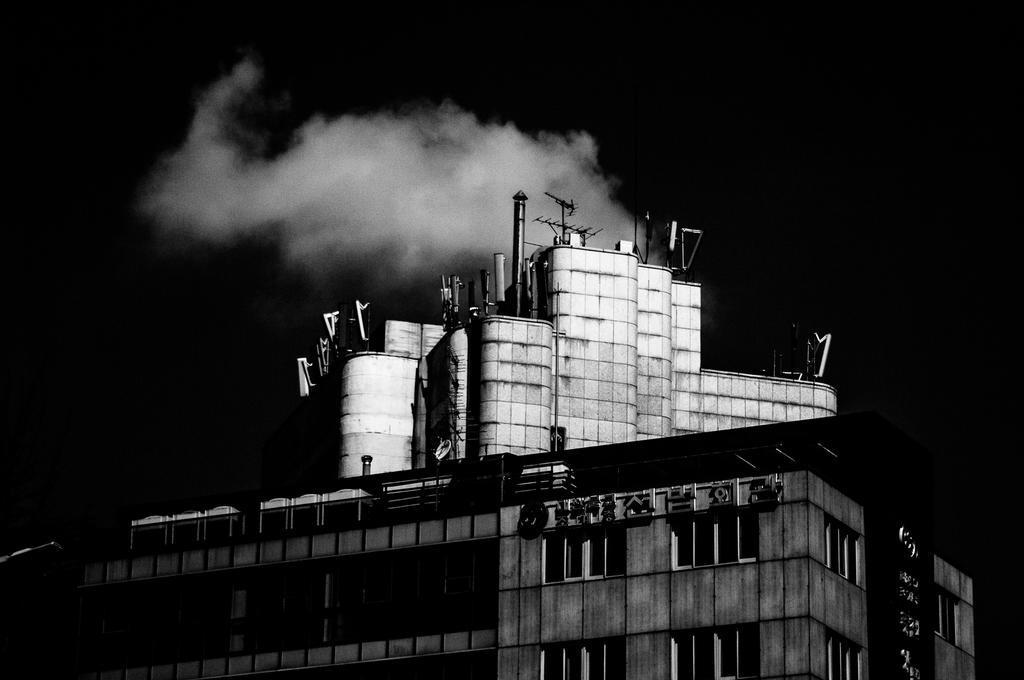In one or two sentences, can you explain what this image depicts? These picture is in black and white. At the bottom, there is a factory releasing gases. 